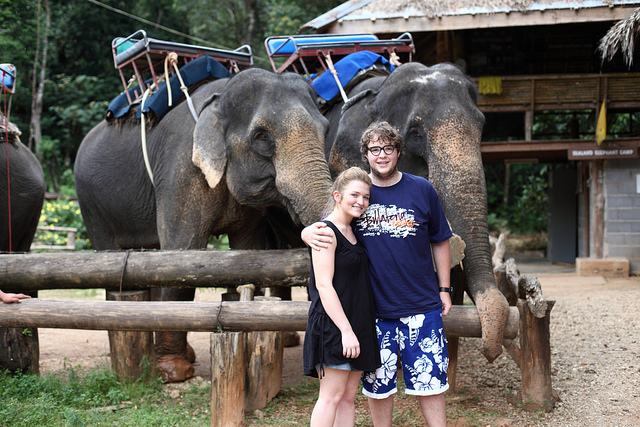<image>Are they married couple? I don't know if they are a married couple. Are they married couple? I am not sure if they are a married couple. It is possible that they are, but I cannot determine for certain. 